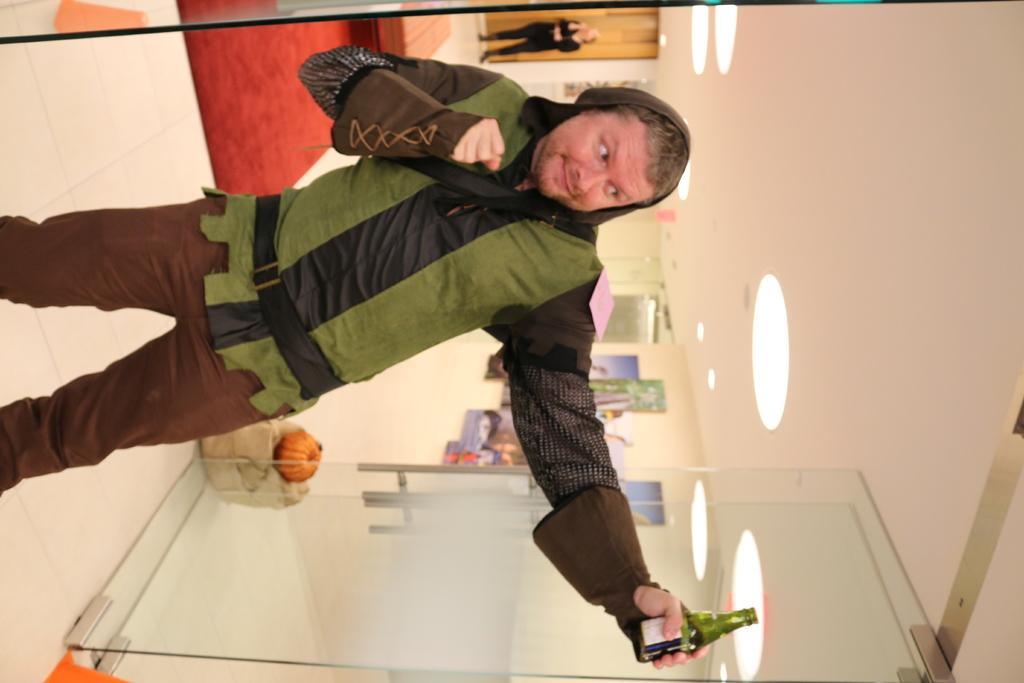Could you give a brief overview of what you see in this image? This person standing and holding bottle. This is floor. This is glass door. On the top we can see lights. A far there is a person standing. 